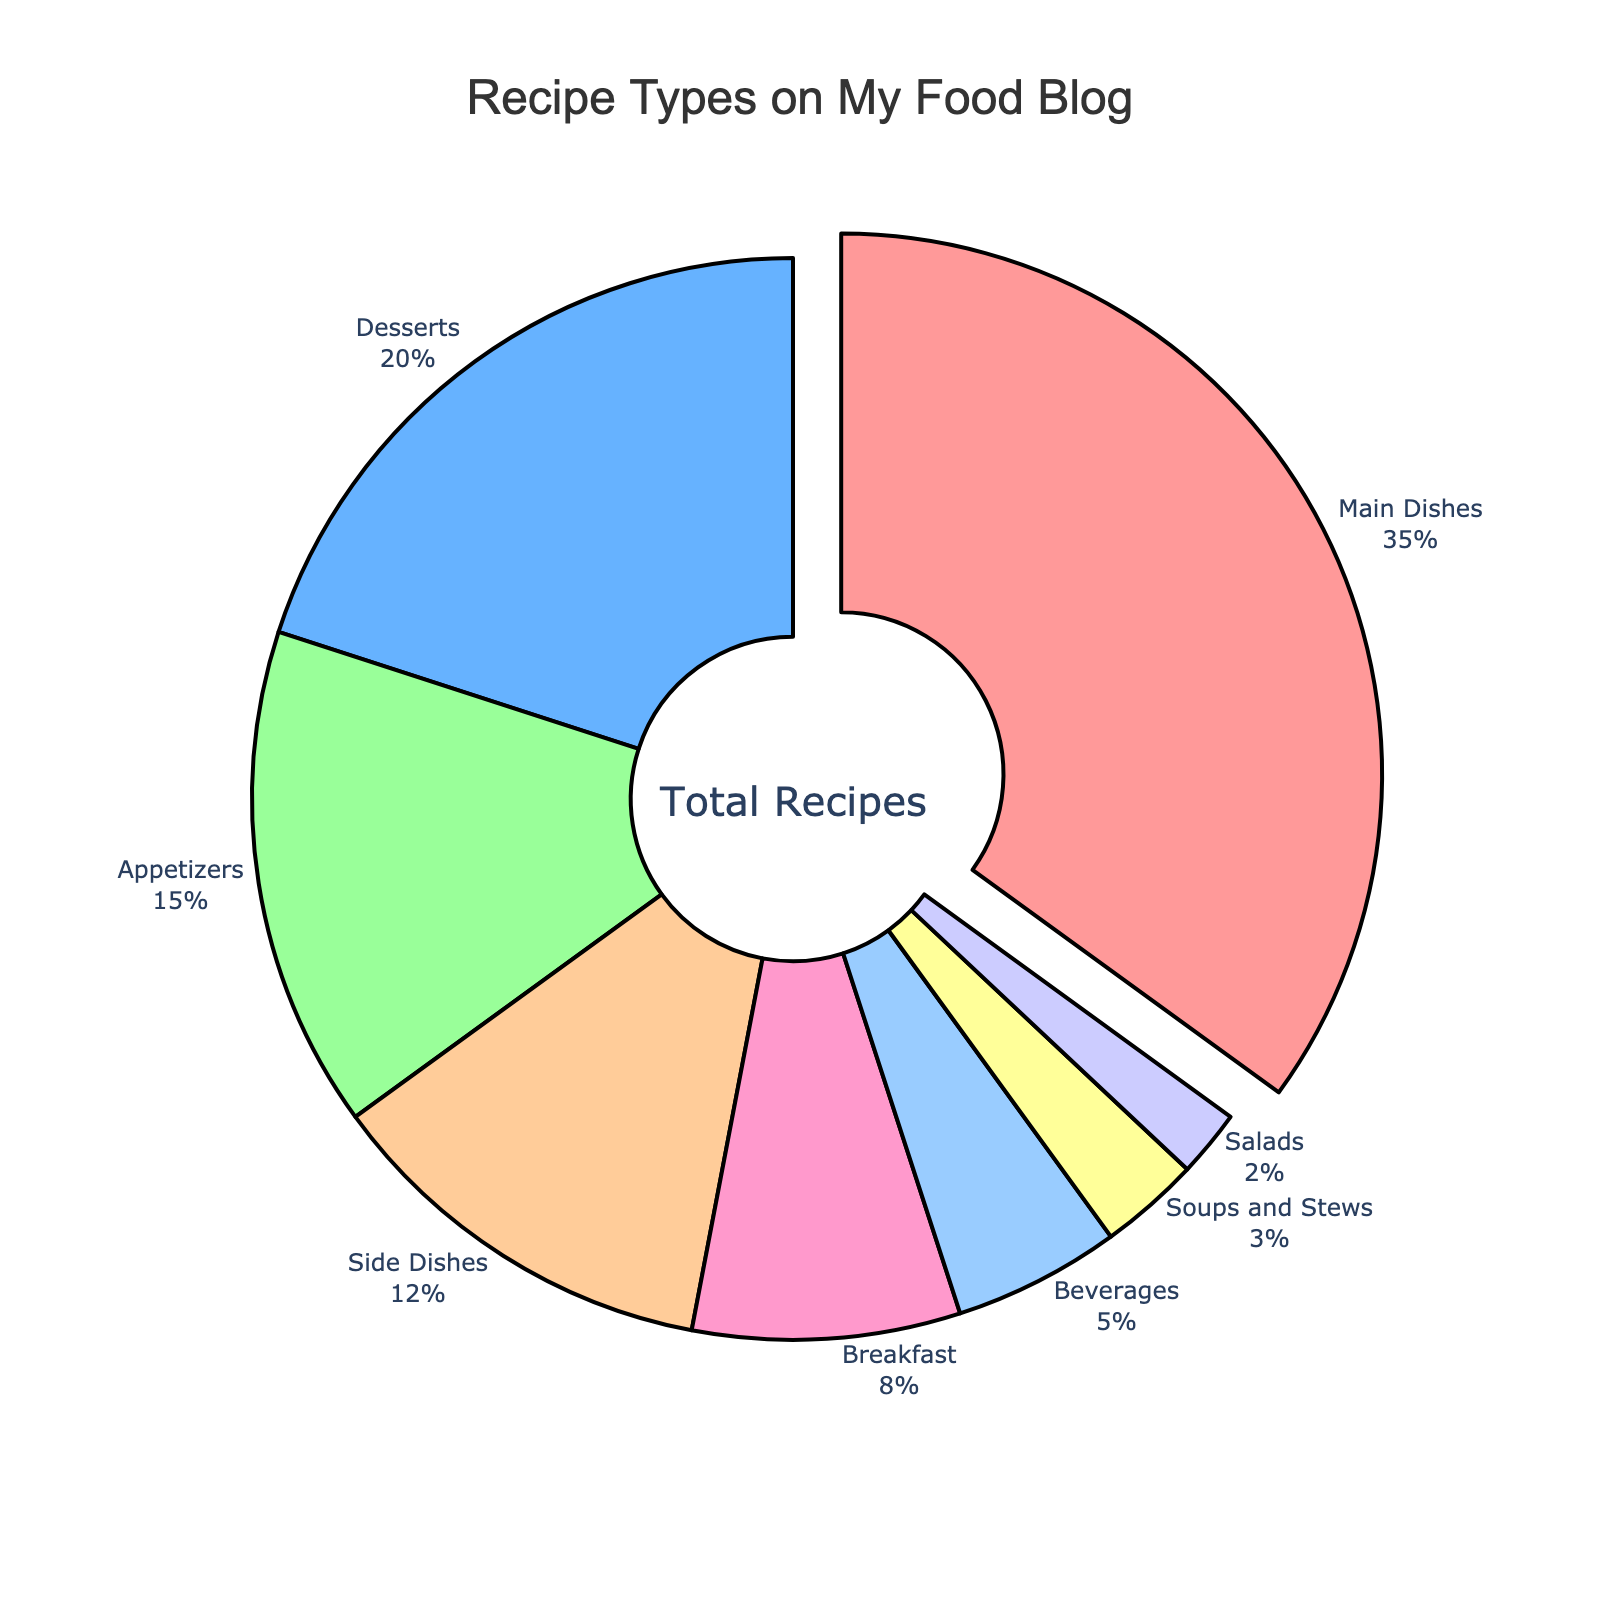Which type of recipe has the highest proportion on the blog? The Main Dishes category is the largest segment in the pie chart and is visually represented as the one pulled out of the pie. This indicates that it has the highest proportion among all recipe types featured.
Answer: Main Dishes How does the percentage of Breakfast recipes compare to the percentage of Desserts recipes? The pie chart shows that Breakfast recipes account for 8% and Desserts make up 20%. To compare, 8% is less than 20%, meaning Breakfast recipes are featured less frequently than Desserts.
Answer: Breakfast recipes are less What's the combined percentage of Side Dishes and Beverages? From the pie chart, Side Dishes account for 12% and Beverages make up 5%. Adding these together: 12% + 5% = 17%. Hence, the combined percentage is 17%.
Answer: 17% If you combined the percentages of Soups and Stews with Appetizers, how would this compare to Main Dishes? Soups and Stews are 3% and Appetizers are 15%. Together they sum to 3% + 15% = 18%. Main Dishes are 35%. Comparing the two, 18% is less than 35%.
Answer: Less than Main Dishes What is the percentage difference between the least featured recipe type and the most featured type? The least featured type is Salads at 2%, and the most featured type is Main Dishes at 35%. The difference is 35% - 2% = 33%.
Answer: 33% Which two categories together make up 28% of the recipes? The chart provides these percentages: Main Dishes (35%), Desserts (20%), Appetizers (15%), Side Dishes (12%), Breakfast (8%), Beverages (5%), Soups and Stews (3%), Salads (2%). Adding 20% (Desserts) and 8% (Breakfast) gives 28%.
Answer: Desserts and Breakfast If the blog wants to increase the percentage of Beverages to match that of Side Dishes, by how much would the percentage of Beverages need to increase? Currently, Beverages are at 5%, and Side Dishes stand at 12%. To match Side Dishes, Beverages need an increase of 12% - 5% = 7%.
Answer: 7% What proportion of the pie chart is made up of categories other than Main Dishes? Main Dishes are 35%, so the remainder is 100% - 35% = 65%. Every other type combined makes up 65%.
Answer: 65% Is the portion for Soups and Stews larger, smaller, or the same as the combined portion for Salads and Beverages? Soups and Stews account for 3%. Salads and Beverages together are 2% + 5% = 7%. Therefore, Soups and Stews are smaller.
Answer: Smaller 